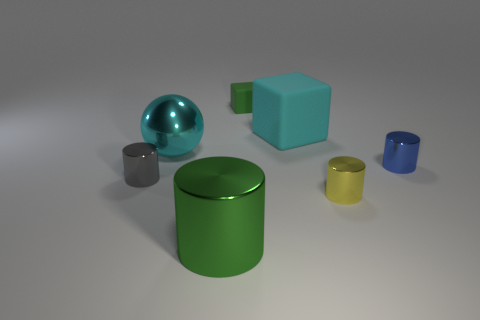What could be the possible use of these objects? These objects could serve as models for educational purposes in geometry or demonstrations of shading and lighting in a visual arts context. They might also be components in abstract decor. 